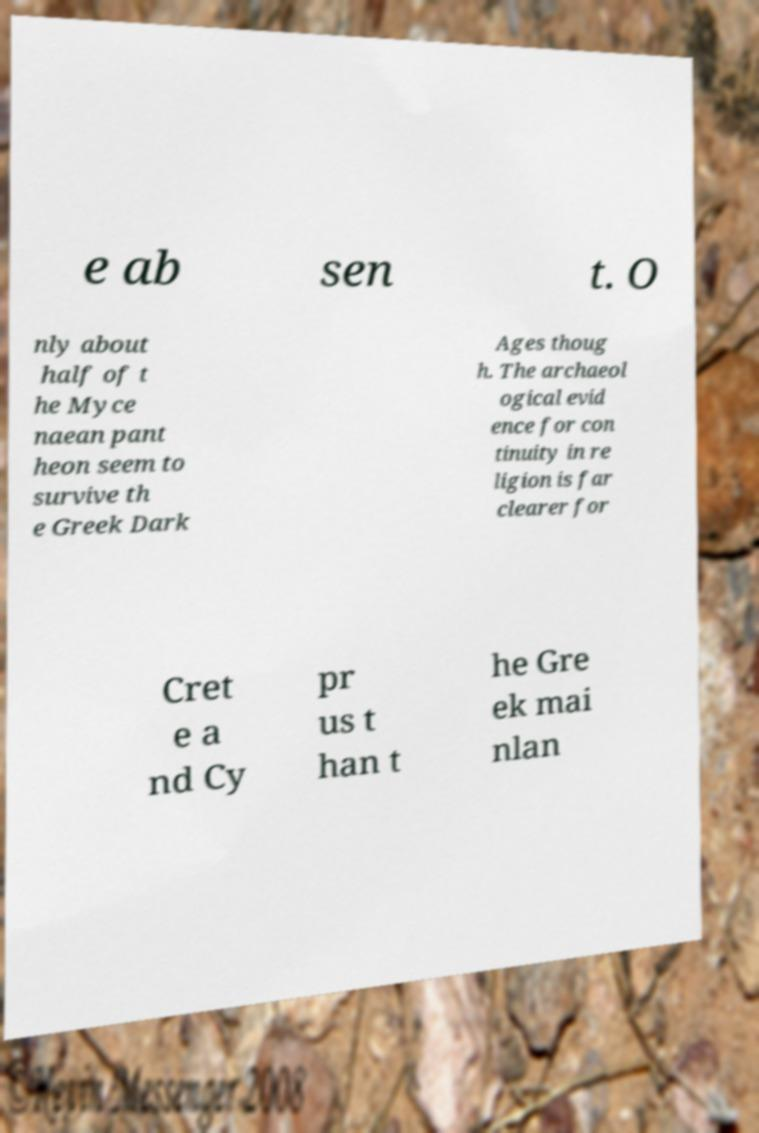Can you read and provide the text displayed in the image?This photo seems to have some interesting text. Can you extract and type it out for me? e ab sen t. O nly about half of t he Myce naean pant heon seem to survive th e Greek Dark Ages thoug h. The archaeol ogical evid ence for con tinuity in re ligion is far clearer for Cret e a nd Cy pr us t han t he Gre ek mai nlan 